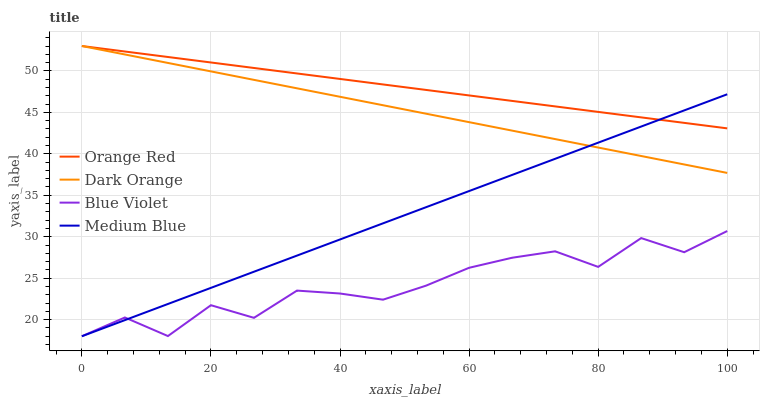Does Medium Blue have the minimum area under the curve?
Answer yes or no. No. Does Medium Blue have the maximum area under the curve?
Answer yes or no. No. Is Medium Blue the smoothest?
Answer yes or no. No. Is Medium Blue the roughest?
Answer yes or no. No. Does Orange Red have the lowest value?
Answer yes or no. No. Does Medium Blue have the highest value?
Answer yes or no. No. Is Blue Violet less than Orange Red?
Answer yes or no. Yes. Is Dark Orange greater than Blue Violet?
Answer yes or no. Yes. Does Blue Violet intersect Orange Red?
Answer yes or no. No. 